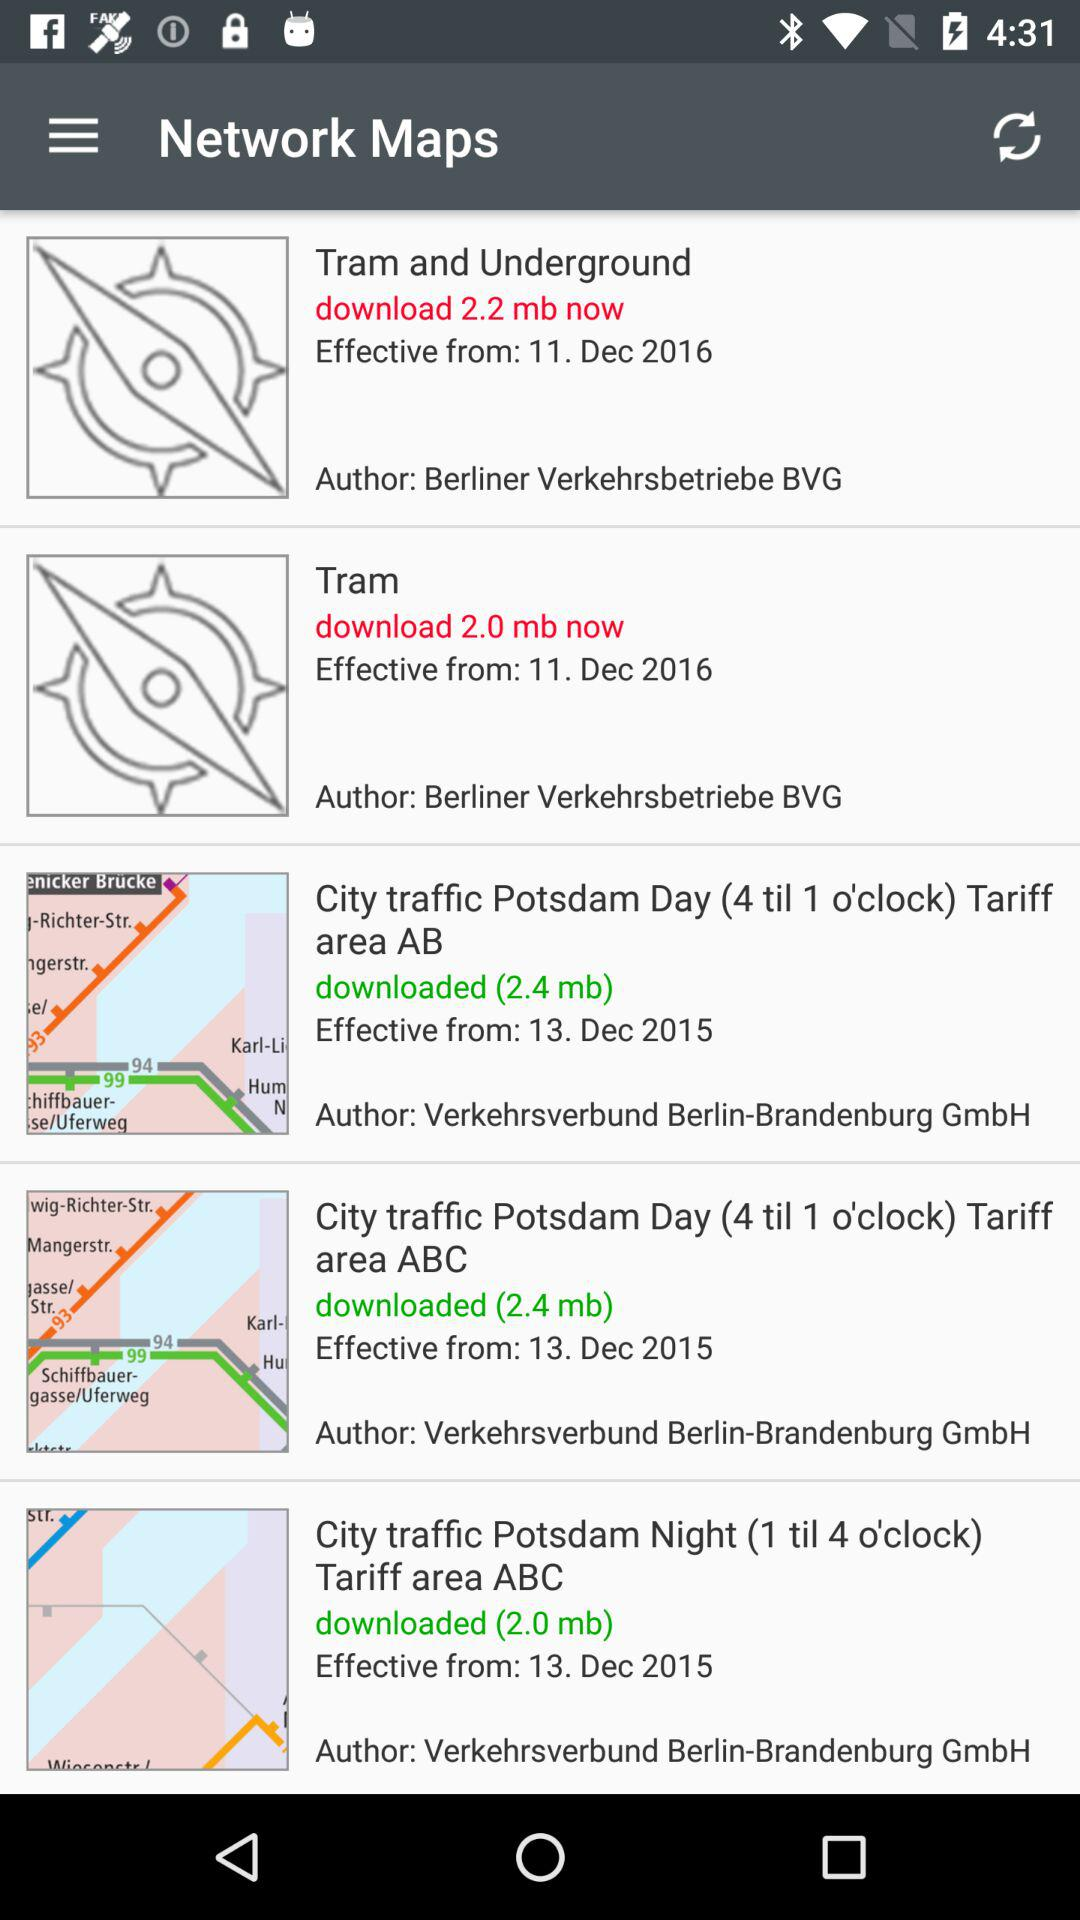What is the effective date of the "City traffic Potsdam Day (4 till 1 o'clock) Tariff area ABC"? The effective date of the "City traffic Potsdam Day (4 till 1 o'clock) Tariff area ABC" is December 13, 2015. 